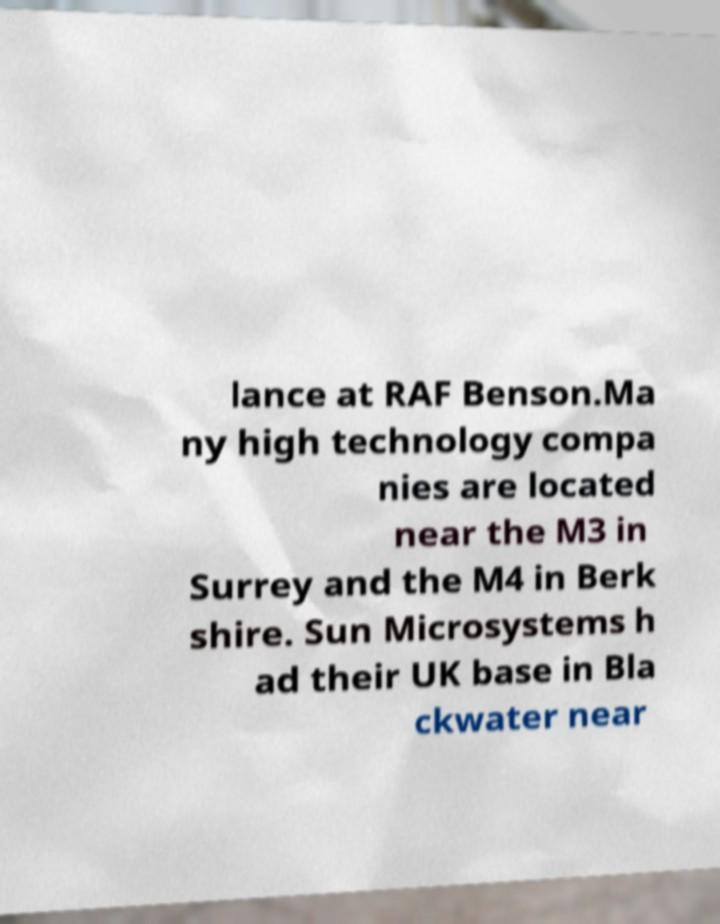Please identify and transcribe the text found in this image. lance at RAF Benson.Ma ny high technology compa nies are located near the M3 in Surrey and the M4 in Berk shire. Sun Microsystems h ad their UK base in Bla ckwater near 